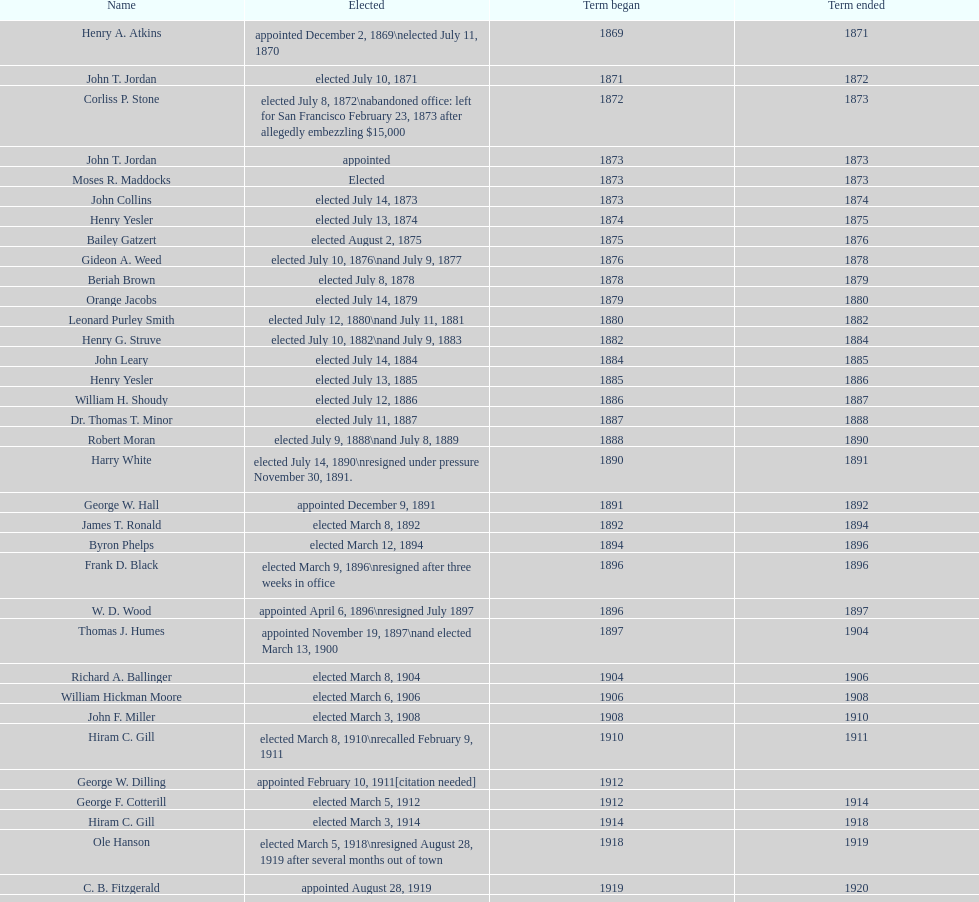Did charles royer hold office longer than paul schell? Yes. 